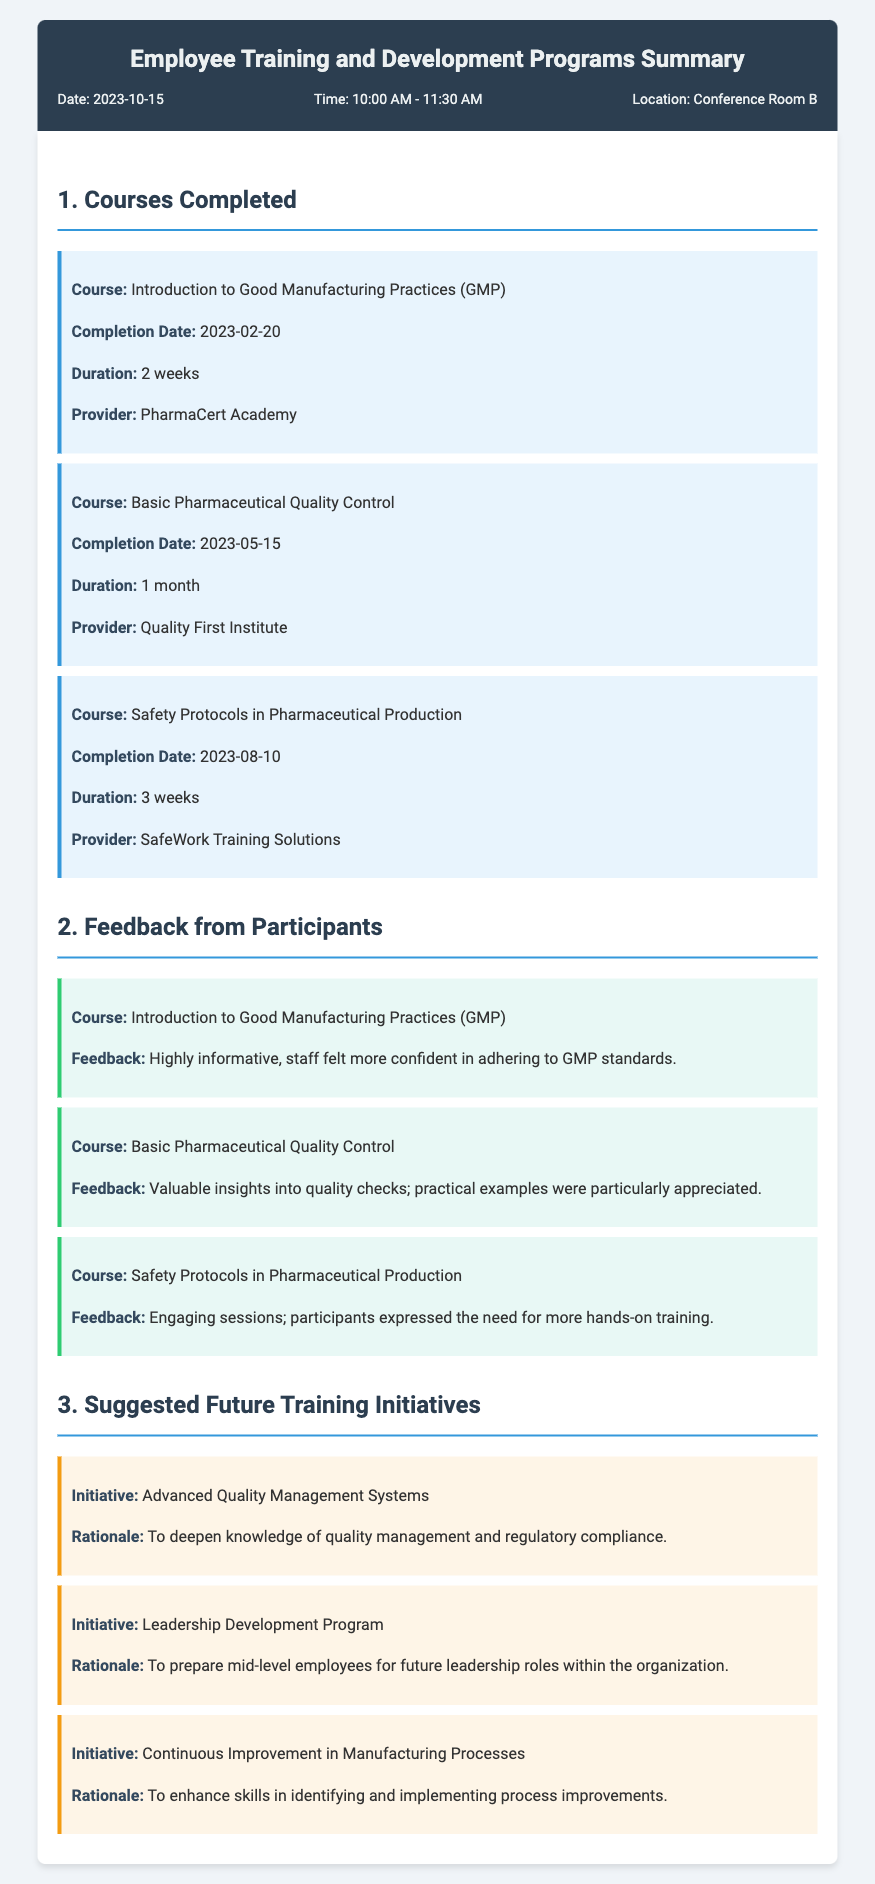What is the date of the document? The date of the document is mentioned in the header section, which states "Date: 2023-10-15."
Answer: 2023-10-15 What course was completed on 2023-02-20? The course that was completed on this date is listed under "Courses Completed" with the details for that particular course.
Answer: Introduction to Good Manufacturing Practices (GMP) How long was the "Basic Pharmaceutical Quality Control" course? The duration of the course is provided in the courses section and indicates how long the training lasted.
Answer: 1 month What feedback was given for the "Safety Protocols in Pharmaceutical Production" course? The feedback section contains evaluations of specific courses, including comments about this course.
Answer: Engaging sessions; participants expressed the need for more hands-on training What is one suggested future training initiative? The suggested initiatives are presented in a specific section and highlight future training opportunities.
Answer: Advanced Quality Management Systems What was the rationale for the "Leadership Development Program"? The rationale is detailed for each suggested initiative and explains its purpose for future training programs.
Answer: To prepare mid-level employees for future leadership roles within the organization How many courses are listed under "Courses Completed"? The number of courses can be counted from the section detailing completed courses.
Answer: 3 What is the completion date for the "Safety Protocols in Pharmaceutical Production" course? The completion date is explicitly stated next to the course title in the completed courses section.
Answer: 2023-08-10 